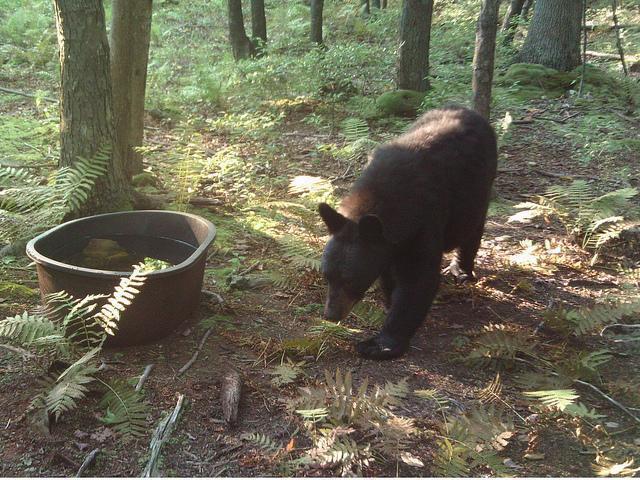How many of the buses are blue?
Give a very brief answer. 0. 